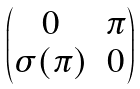<formula> <loc_0><loc_0><loc_500><loc_500>\begin{pmatrix} 0 & \pi \\ \sigma ( \pi ) & 0 \end{pmatrix}</formula> 